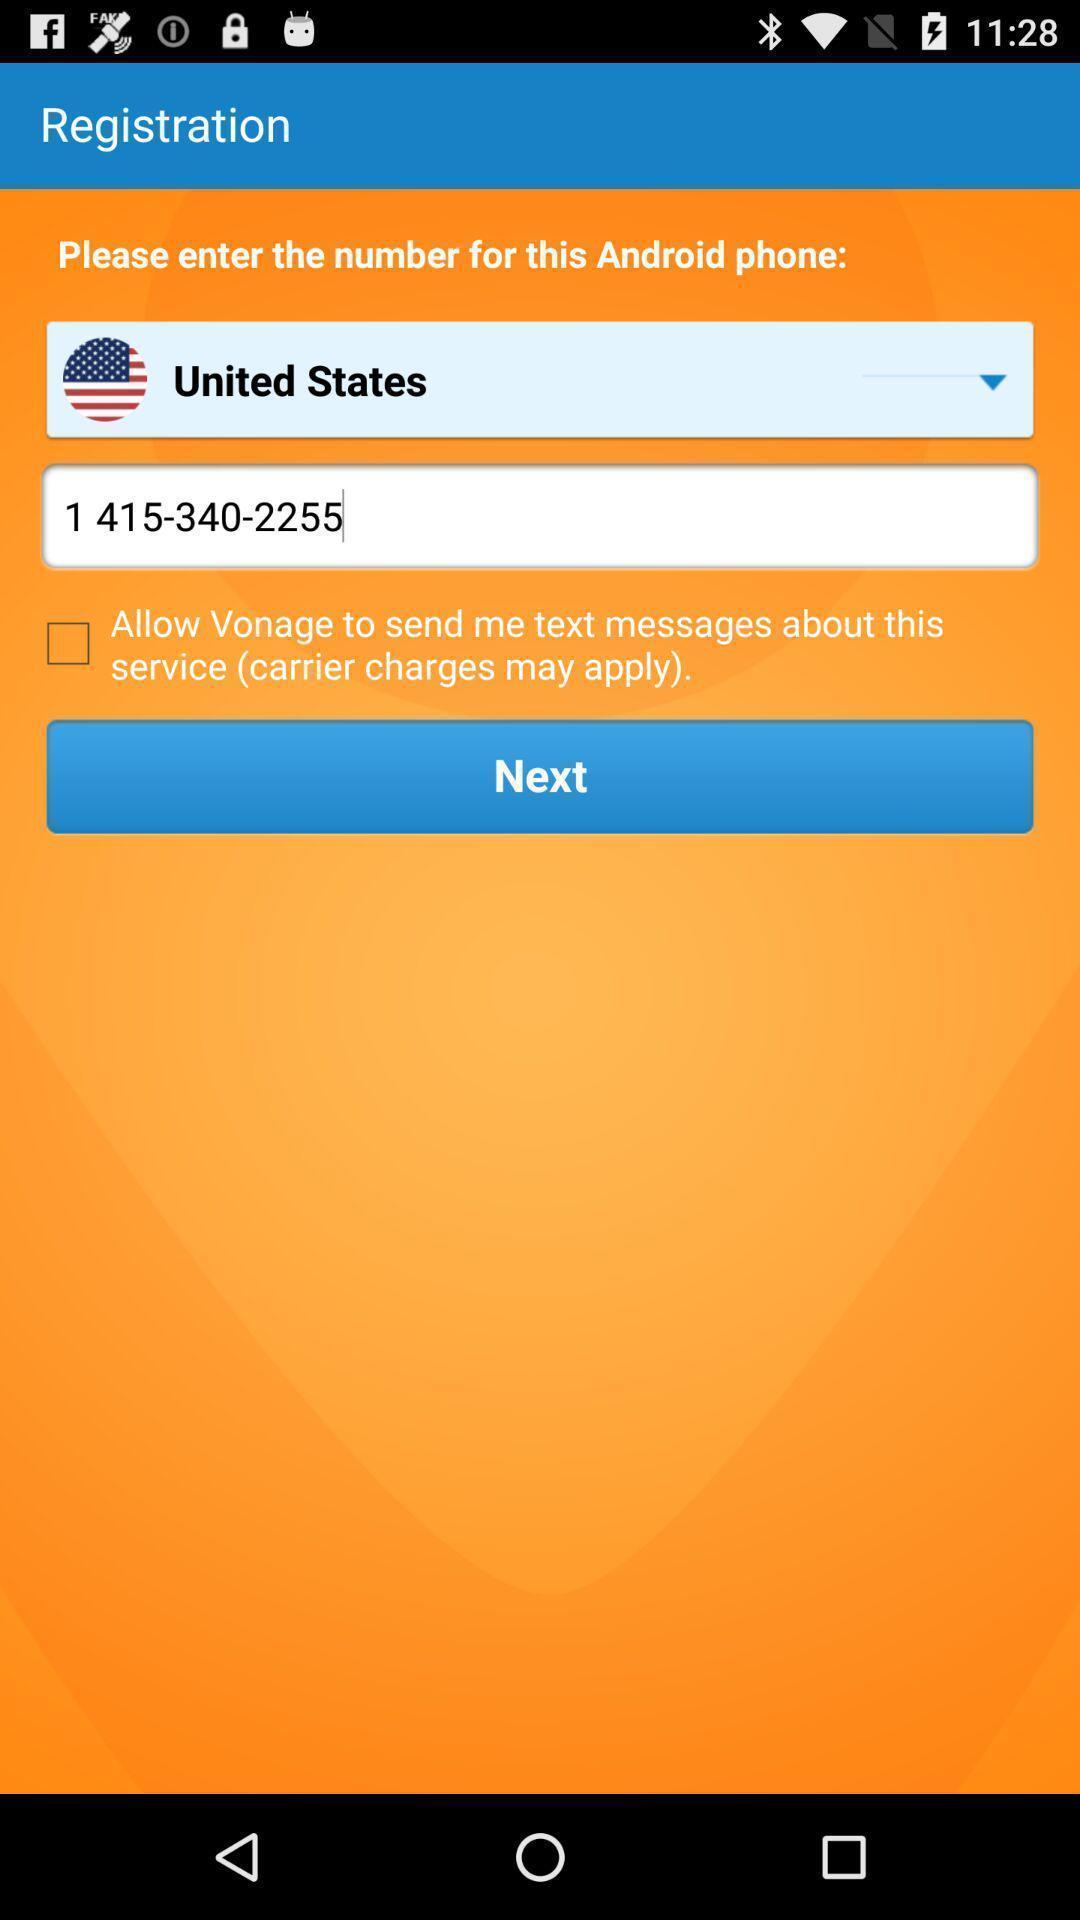Describe the key features of this screenshot. Screen shows registration details. 